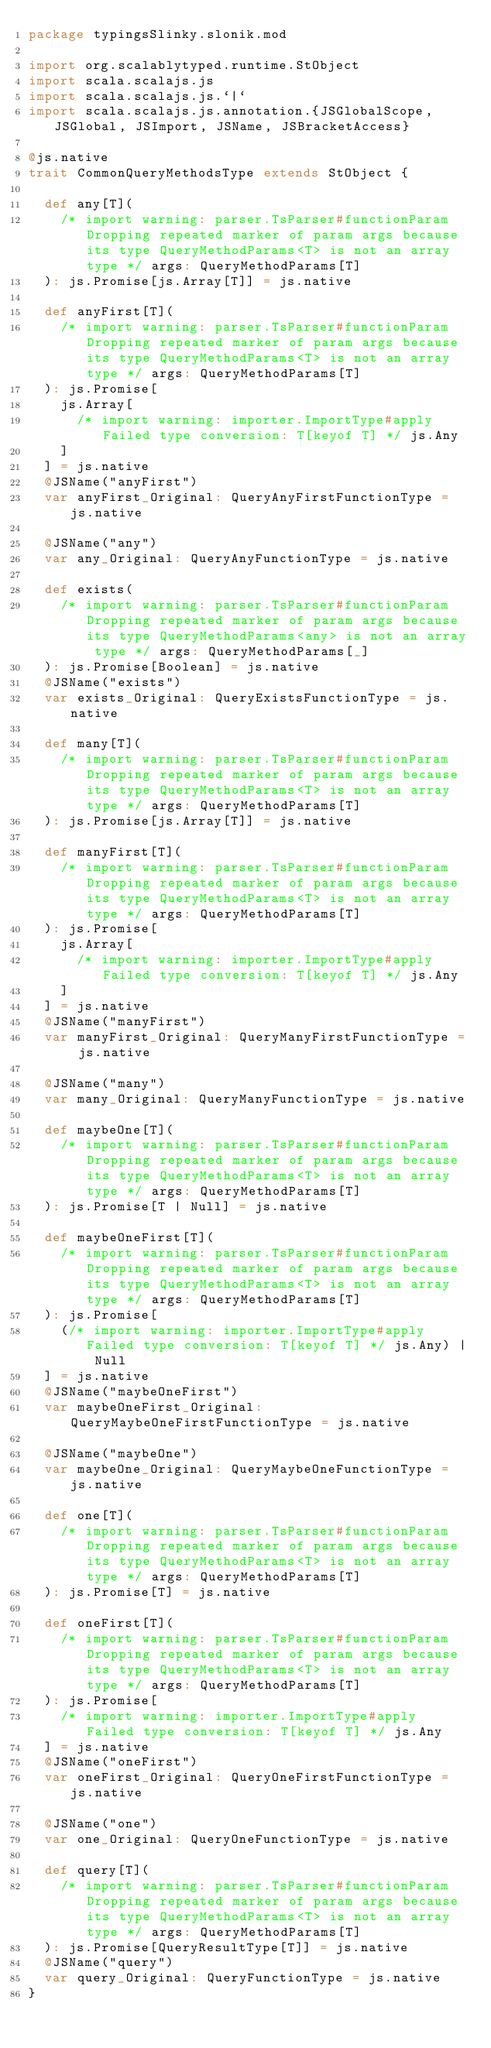Convert code to text. <code><loc_0><loc_0><loc_500><loc_500><_Scala_>package typingsSlinky.slonik.mod

import org.scalablytyped.runtime.StObject
import scala.scalajs.js
import scala.scalajs.js.`|`
import scala.scalajs.js.annotation.{JSGlobalScope, JSGlobal, JSImport, JSName, JSBracketAccess}

@js.native
trait CommonQueryMethodsType extends StObject {
  
  def any[T](
    /* import warning: parser.TsParser#functionParam Dropping repeated marker of param args because its type QueryMethodParams<T> is not an array type */ args: QueryMethodParams[T]
  ): js.Promise[js.Array[T]] = js.native
  
  def anyFirst[T](
    /* import warning: parser.TsParser#functionParam Dropping repeated marker of param args because its type QueryMethodParams<T> is not an array type */ args: QueryMethodParams[T]
  ): js.Promise[
    js.Array[
      /* import warning: importer.ImportType#apply Failed type conversion: T[keyof T] */ js.Any
    ]
  ] = js.native
  @JSName("anyFirst")
  var anyFirst_Original: QueryAnyFirstFunctionType = js.native
  
  @JSName("any")
  var any_Original: QueryAnyFunctionType = js.native
  
  def exists(
    /* import warning: parser.TsParser#functionParam Dropping repeated marker of param args because its type QueryMethodParams<any> is not an array type */ args: QueryMethodParams[_]
  ): js.Promise[Boolean] = js.native
  @JSName("exists")
  var exists_Original: QueryExistsFunctionType = js.native
  
  def many[T](
    /* import warning: parser.TsParser#functionParam Dropping repeated marker of param args because its type QueryMethodParams<T> is not an array type */ args: QueryMethodParams[T]
  ): js.Promise[js.Array[T]] = js.native
  
  def manyFirst[T](
    /* import warning: parser.TsParser#functionParam Dropping repeated marker of param args because its type QueryMethodParams<T> is not an array type */ args: QueryMethodParams[T]
  ): js.Promise[
    js.Array[
      /* import warning: importer.ImportType#apply Failed type conversion: T[keyof T] */ js.Any
    ]
  ] = js.native
  @JSName("manyFirst")
  var manyFirst_Original: QueryManyFirstFunctionType = js.native
  
  @JSName("many")
  var many_Original: QueryManyFunctionType = js.native
  
  def maybeOne[T](
    /* import warning: parser.TsParser#functionParam Dropping repeated marker of param args because its type QueryMethodParams<T> is not an array type */ args: QueryMethodParams[T]
  ): js.Promise[T | Null] = js.native
  
  def maybeOneFirst[T](
    /* import warning: parser.TsParser#functionParam Dropping repeated marker of param args because its type QueryMethodParams<T> is not an array type */ args: QueryMethodParams[T]
  ): js.Promise[
    (/* import warning: importer.ImportType#apply Failed type conversion: T[keyof T] */ js.Any) | Null
  ] = js.native
  @JSName("maybeOneFirst")
  var maybeOneFirst_Original: QueryMaybeOneFirstFunctionType = js.native
  
  @JSName("maybeOne")
  var maybeOne_Original: QueryMaybeOneFunctionType = js.native
  
  def one[T](
    /* import warning: parser.TsParser#functionParam Dropping repeated marker of param args because its type QueryMethodParams<T> is not an array type */ args: QueryMethodParams[T]
  ): js.Promise[T] = js.native
  
  def oneFirst[T](
    /* import warning: parser.TsParser#functionParam Dropping repeated marker of param args because its type QueryMethodParams<T> is not an array type */ args: QueryMethodParams[T]
  ): js.Promise[
    /* import warning: importer.ImportType#apply Failed type conversion: T[keyof T] */ js.Any
  ] = js.native
  @JSName("oneFirst")
  var oneFirst_Original: QueryOneFirstFunctionType = js.native
  
  @JSName("one")
  var one_Original: QueryOneFunctionType = js.native
  
  def query[T](
    /* import warning: parser.TsParser#functionParam Dropping repeated marker of param args because its type QueryMethodParams<T> is not an array type */ args: QueryMethodParams[T]
  ): js.Promise[QueryResultType[T]] = js.native
  @JSName("query")
  var query_Original: QueryFunctionType = js.native
}
</code> 